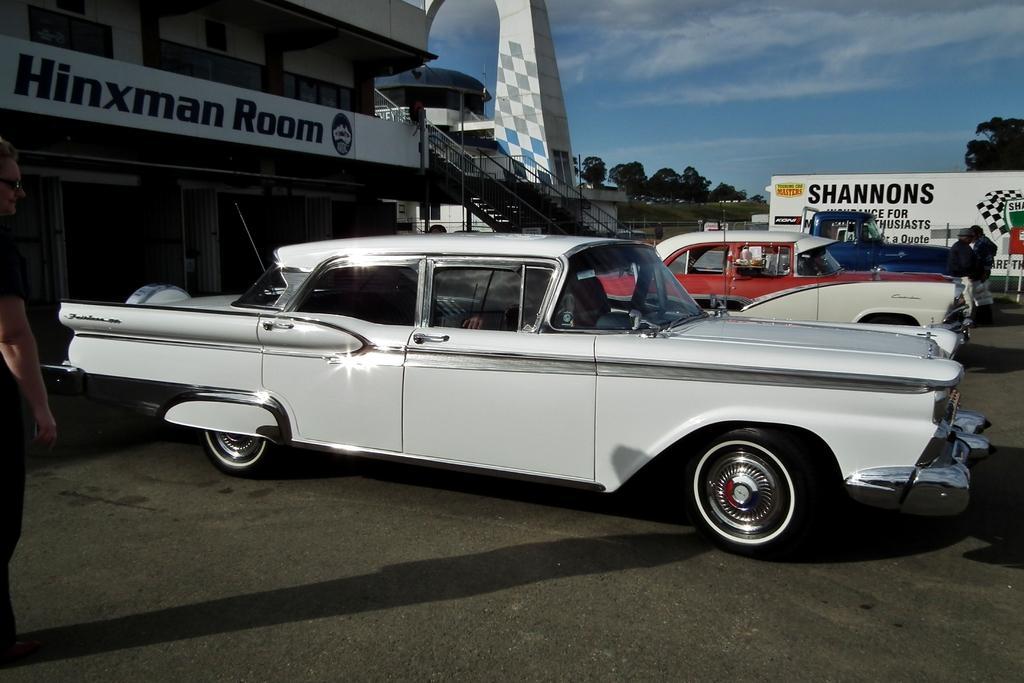Please provide a concise description of this image. In this picture we can see few vehicles, buildings and group of people, in the background we can find a hoarding, few trees and clouds. 